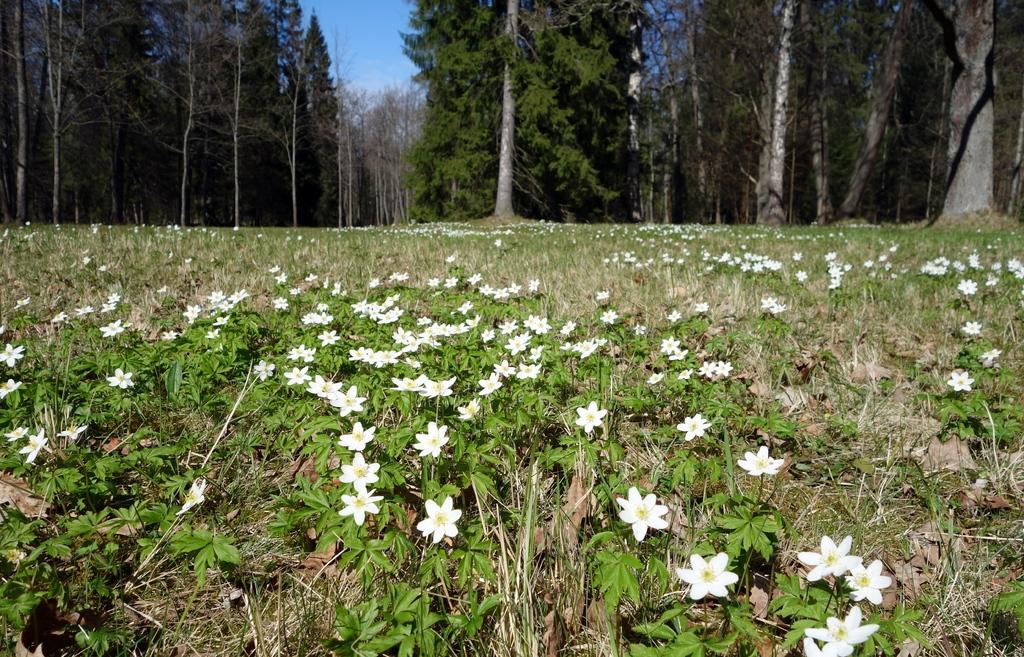What type of plants are in the image? There are white flower plants in the image. What can be seen in the background of the image? There are trees at the back of the image. What is visible at the top of the image? The sky is visible at the top of the image. Where is the grandmother sitting in the image? There is no grandmother present in the image. How many fingers can be seen on the plants in the image? Plants do not have fingers, so this question cannot be answered. 